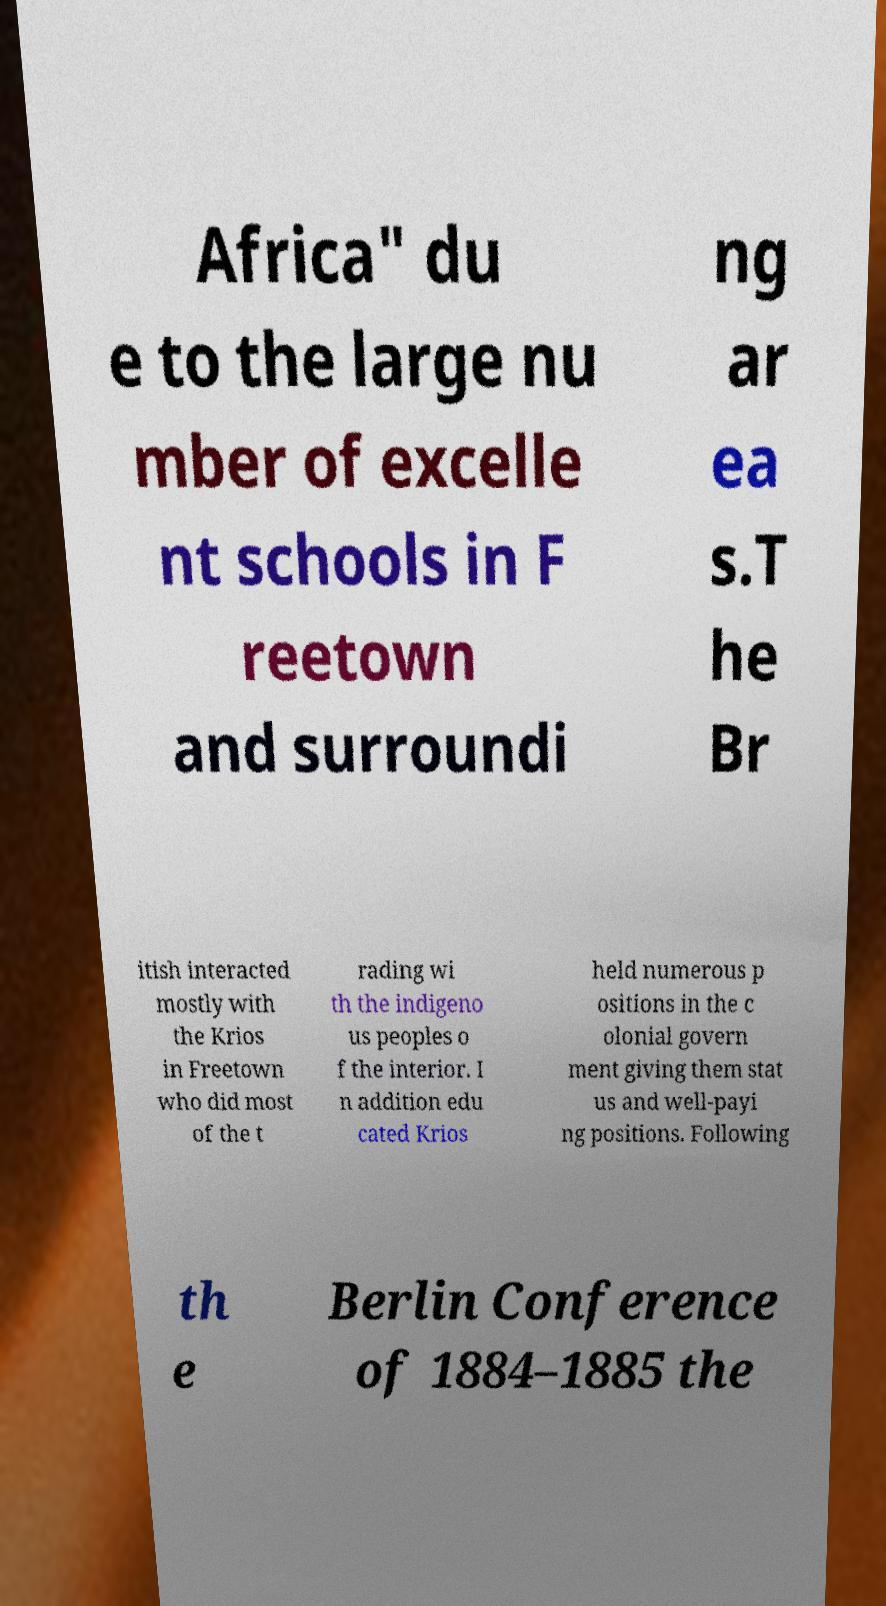For documentation purposes, I need the text within this image transcribed. Could you provide that? Africa" du e to the large nu mber of excelle nt schools in F reetown and surroundi ng ar ea s.T he Br itish interacted mostly with the Krios in Freetown who did most of the t rading wi th the indigeno us peoples o f the interior. I n addition edu cated Krios held numerous p ositions in the c olonial govern ment giving them stat us and well-payi ng positions. Following th e Berlin Conference of 1884–1885 the 